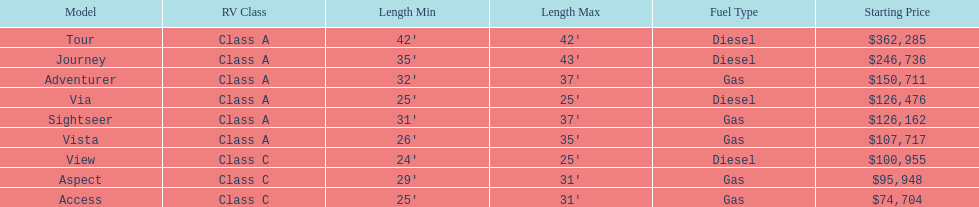Which model is at the top of the list with the highest starting price? Tour. 